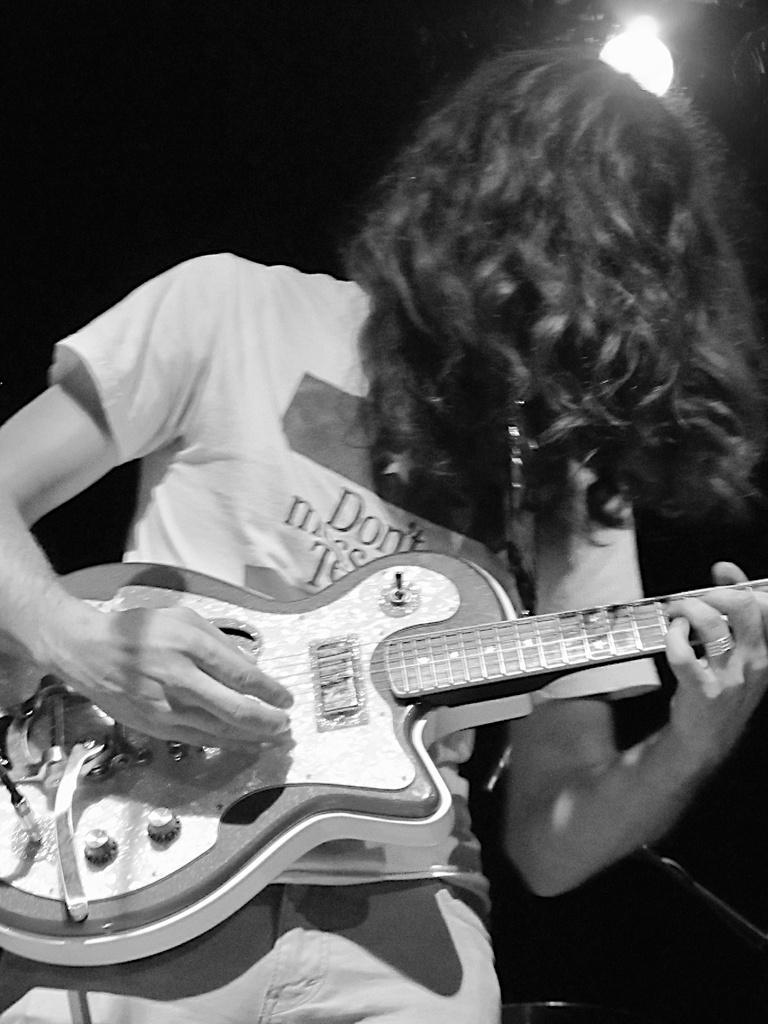Please provide a concise description of this image. A black and white picture. A person is playing this guitar. On top there is a focusing light. 